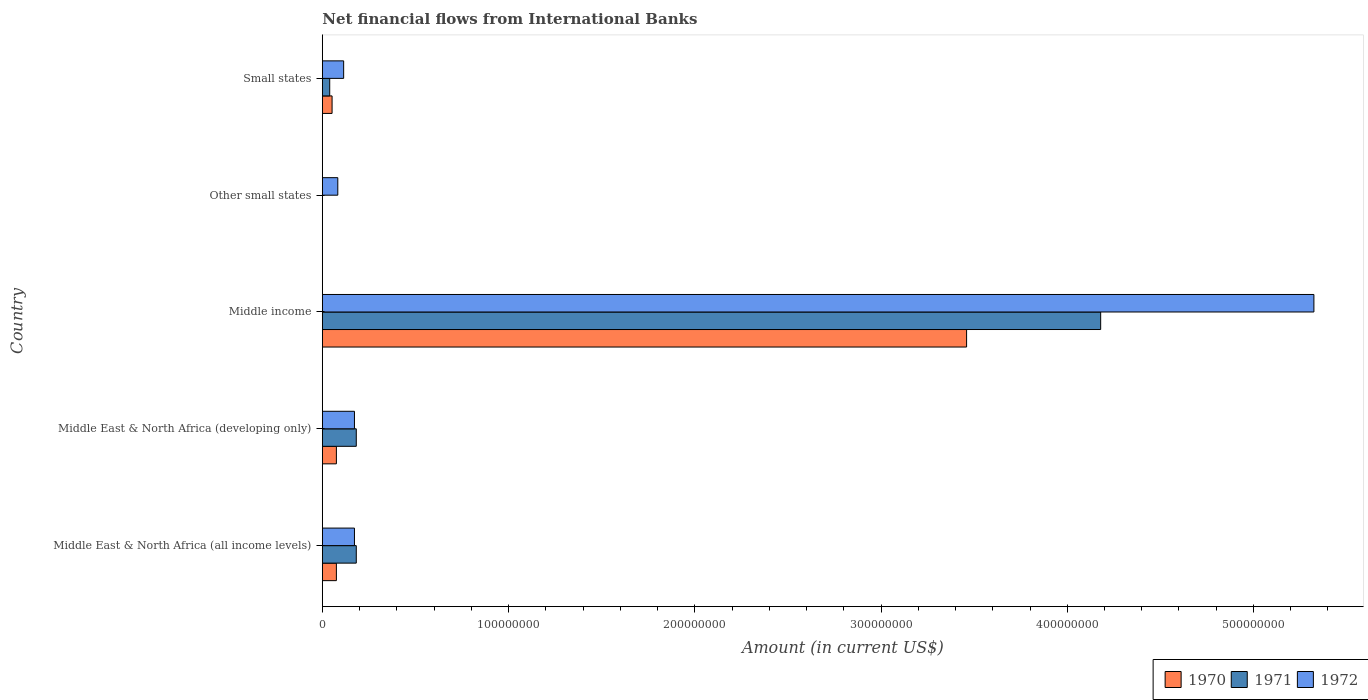How many different coloured bars are there?
Provide a succinct answer. 3. Are the number of bars per tick equal to the number of legend labels?
Make the answer very short. No. How many bars are there on the 1st tick from the bottom?
Offer a terse response. 3. What is the label of the 2nd group of bars from the top?
Your answer should be very brief. Other small states. What is the net financial aid flows in 1972 in Middle East & North Africa (developing only)?
Your response must be concise. 1.73e+07. Across all countries, what is the maximum net financial aid flows in 1972?
Your answer should be compact. 5.32e+08. Across all countries, what is the minimum net financial aid flows in 1970?
Offer a very short reply. 0. In which country was the net financial aid flows in 1972 maximum?
Your answer should be compact. Middle income. What is the total net financial aid flows in 1972 in the graph?
Offer a very short reply. 5.87e+08. What is the difference between the net financial aid flows in 1972 in Middle East & North Africa (developing only) and that in Small states?
Offer a very short reply. 5.80e+06. What is the difference between the net financial aid flows in 1972 in Other small states and the net financial aid flows in 1970 in Small states?
Offer a very short reply. 3.07e+06. What is the average net financial aid flows in 1970 per country?
Your answer should be very brief. 7.33e+07. What is the difference between the net financial aid flows in 1971 and net financial aid flows in 1970 in Middle East & North Africa (developing only)?
Your answer should be compact. 1.07e+07. In how many countries, is the net financial aid flows in 1972 greater than 120000000 US$?
Offer a very short reply. 1. What is the ratio of the net financial aid flows in 1972 in Middle East & North Africa (all income levels) to that in Middle income?
Provide a succinct answer. 0.03. Is the difference between the net financial aid flows in 1971 in Middle East & North Africa (all income levels) and Middle East & North Africa (developing only) greater than the difference between the net financial aid flows in 1970 in Middle East & North Africa (all income levels) and Middle East & North Africa (developing only)?
Give a very brief answer. No. What is the difference between the highest and the second highest net financial aid flows in 1970?
Provide a short and direct response. 3.38e+08. What is the difference between the highest and the lowest net financial aid flows in 1972?
Your response must be concise. 5.24e+08. Is the sum of the net financial aid flows in 1971 in Middle East & North Africa (all income levels) and Middle East & North Africa (developing only) greater than the maximum net financial aid flows in 1972 across all countries?
Offer a terse response. No. What is the difference between two consecutive major ticks on the X-axis?
Your response must be concise. 1.00e+08. Does the graph contain any zero values?
Provide a short and direct response. Yes. How many legend labels are there?
Give a very brief answer. 3. What is the title of the graph?
Your answer should be very brief. Net financial flows from International Banks. Does "1968" appear as one of the legend labels in the graph?
Provide a succinct answer. No. What is the label or title of the X-axis?
Your response must be concise. Amount (in current US$). What is the Amount (in current US$) in 1970 in Middle East & North Africa (all income levels)?
Ensure brevity in your answer.  7.55e+06. What is the Amount (in current US$) of 1971 in Middle East & North Africa (all income levels)?
Your answer should be very brief. 1.82e+07. What is the Amount (in current US$) in 1972 in Middle East & North Africa (all income levels)?
Provide a short and direct response. 1.73e+07. What is the Amount (in current US$) of 1970 in Middle East & North Africa (developing only)?
Offer a terse response. 7.55e+06. What is the Amount (in current US$) in 1971 in Middle East & North Africa (developing only)?
Keep it short and to the point. 1.82e+07. What is the Amount (in current US$) in 1972 in Middle East & North Africa (developing only)?
Provide a succinct answer. 1.73e+07. What is the Amount (in current US$) in 1970 in Middle income?
Keep it short and to the point. 3.46e+08. What is the Amount (in current US$) in 1971 in Middle income?
Give a very brief answer. 4.18e+08. What is the Amount (in current US$) of 1972 in Middle income?
Your response must be concise. 5.32e+08. What is the Amount (in current US$) of 1970 in Other small states?
Your answer should be very brief. 0. What is the Amount (in current US$) of 1971 in Other small states?
Ensure brevity in your answer.  0. What is the Amount (in current US$) of 1972 in Other small states?
Provide a succinct answer. 8.31e+06. What is the Amount (in current US$) of 1970 in Small states?
Your answer should be very brief. 5.24e+06. What is the Amount (in current US$) in 1971 in Small states?
Ensure brevity in your answer.  3.97e+06. What is the Amount (in current US$) of 1972 in Small states?
Your response must be concise. 1.15e+07. Across all countries, what is the maximum Amount (in current US$) in 1970?
Your response must be concise. 3.46e+08. Across all countries, what is the maximum Amount (in current US$) of 1971?
Offer a very short reply. 4.18e+08. Across all countries, what is the maximum Amount (in current US$) in 1972?
Your answer should be compact. 5.32e+08. Across all countries, what is the minimum Amount (in current US$) of 1971?
Your answer should be compact. 0. Across all countries, what is the minimum Amount (in current US$) of 1972?
Your answer should be very brief. 8.31e+06. What is the total Amount (in current US$) of 1970 in the graph?
Your answer should be very brief. 3.66e+08. What is the total Amount (in current US$) of 1971 in the graph?
Make the answer very short. 4.58e+08. What is the total Amount (in current US$) of 1972 in the graph?
Provide a short and direct response. 5.87e+08. What is the difference between the Amount (in current US$) of 1971 in Middle East & North Africa (all income levels) and that in Middle East & North Africa (developing only)?
Make the answer very short. 0. What is the difference between the Amount (in current US$) of 1972 in Middle East & North Africa (all income levels) and that in Middle East & North Africa (developing only)?
Keep it short and to the point. 0. What is the difference between the Amount (in current US$) of 1970 in Middle East & North Africa (all income levels) and that in Middle income?
Provide a short and direct response. -3.38e+08. What is the difference between the Amount (in current US$) in 1971 in Middle East & North Africa (all income levels) and that in Middle income?
Your answer should be very brief. -4.00e+08. What is the difference between the Amount (in current US$) in 1972 in Middle East & North Africa (all income levels) and that in Middle income?
Provide a succinct answer. -5.15e+08. What is the difference between the Amount (in current US$) in 1972 in Middle East & North Africa (all income levels) and that in Other small states?
Your response must be concise. 8.94e+06. What is the difference between the Amount (in current US$) in 1970 in Middle East & North Africa (all income levels) and that in Small states?
Offer a very short reply. 2.31e+06. What is the difference between the Amount (in current US$) of 1971 in Middle East & North Africa (all income levels) and that in Small states?
Offer a terse response. 1.43e+07. What is the difference between the Amount (in current US$) of 1972 in Middle East & North Africa (all income levels) and that in Small states?
Keep it short and to the point. 5.80e+06. What is the difference between the Amount (in current US$) in 1970 in Middle East & North Africa (developing only) and that in Middle income?
Offer a very short reply. -3.38e+08. What is the difference between the Amount (in current US$) of 1971 in Middle East & North Africa (developing only) and that in Middle income?
Your answer should be very brief. -4.00e+08. What is the difference between the Amount (in current US$) in 1972 in Middle East & North Africa (developing only) and that in Middle income?
Offer a very short reply. -5.15e+08. What is the difference between the Amount (in current US$) of 1972 in Middle East & North Africa (developing only) and that in Other small states?
Ensure brevity in your answer.  8.94e+06. What is the difference between the Amount (in current US$) of 1970 in Middle East & North Africa (developing only) and that in Small states?
Keep it short and to the point. 2.31e+06. What is the difference between the Amount (in current US$) in 1971 in Middle East & North Africa (developing only) and that in Small states?
Provide a short and direct response. 1.43e+07. What is the difference between the Amount (in current US$) in 1972 in Middle East & North Africa (developing only) and that in Small states?
Your answer should be very brief. 5.80e+06. What is the difference between the Amount (in current US$) in 1972 in Middle income and that in Other small states?
Offer a terse response. 5.24e+08. What is the difference between the Amount (in current US$) of 1970 in Middle income and that in Small states?
Your answer should be very brief. 3.41e+08. What is the difference between the Amount (in current US$) of 1971 in Middle income and that in Small states?
Provide a short and direct response. 4.14e+08. What is the difference between the Amount (in current US$) of 1972 in Middle income and that in Small states?
Your answer should be compact. 5.21e+08. What is the difference between the Amount (in current US$) of 1972 in Other small states and that in Small states?
Your answer should be compact. -3.15e+06. What is the difference between the Amount (in current US$) of 1970 in Middle East & North Africa (all income levels) and the Amount (in current US$) of 1971 in Middle East & North Africa (developing only)?
Give a very brief answer. -1.07e+07. What is the difference between the Amount (in current US$) of 1970 in Middle East & North Africa (all income levels) and the Amount (in current US$) of 1972 in Middle East & North Africa (developing only)?
Your answer should be very brief. -9.70e+06. What is the difference between the Amount (in current US$) in 1971 in Middle East & North Africa (all income levels) and the Amount (in current US$) in 1972 in Middle East & North Africa (developing only)?
Give a very brief answer. 9.78e+05. What is the difference between the Amount (in current US$) in 1970 in Middle East & North Africa (all income levels) and the Amount (in current US$) in 1971 in Middle income?
Your answer should be very brief. -4.10e+08. What is the difference between the Amount (in current US$) in 1970 in Middle East & North Africa (all income levels) and the Amount (in current US$) in 1972 in Middle income?
Provide a succinct answer. -5.25e+08. What is the difference between the Amount (in current US$) in 1971 in Middle East & North Africa (all income levels) and the Amount (in current US$) in 1972 in Middle income?
Your response must be concise. -5.14e+08. What is the difference between the Amount (in current US$) of 1970 in Middle East & North Africa (all income levels) and the Amount (in current US$) of 1972 in Other small states?
Offer a terse response. -7.62e+05. What is the difference between the Amount (in current US$) in 1971 in Middle East & North Africa (all income levels) and the Amount (in current US$) in 1972 in Other small states?
Your answer should be very brief. 9.92e+06. What is the difference between the Amount (in current US$) in 1970 in Middle East & North Africa (all income levels) and the Amount (in current US$) in 1971 in Small states?
Give a very brief answer. 3.58e+06. What is the difference between the Amount (in current US$) in 1970 in Middle East & North Africa (all income levels) and the Amount (in current US$) in 1972 in Small states?
Provide a short and direct response. -3.91e+06. What is the difference between the Amount (in current US$) in 1971 in Middle East & North Africa (all income levels) and the Amount (in current US$) in 1972 in Small states?
Make the answer very short. 6.77e+06. What is the difference between the Amount (in current US$) in 1970 in Middle East & North Africa (developing only) and the Amount (in current US$) in 1971 in Middle income?
Provide a succinct answer. -4.10e+08. What is the difference between the Amount (in current US$) in 1970 in Middle East & North Africa (developing only) and the Amount (in current US$) in 1972 in Middle income?
Your answer should be compact. -5.25e+08. What is the difference between the Amount (in current US$) in 1971 in Middle East & North Africa (developing only) and the Amount (in current US$) in 1972 in Middle income?
Offer a terse response. -5.14e+08. What is the difference between the Amount (in current US$) of 1970 in Middle East & North Africa (developing only) and the Amount (in current US$) of 1972 in Other small states?
Ensure brevity in your answer.  -7.62e+05. What is the difference between the Amount (in current US$) in 1971 in Middle East & North Africa (developing only) and the Amount (in current US$) in 1972 in Other small states?
Offer a terse response. 9.92e+06. What is the difference between the Amount (in current US$) in 1970 in Middle East & North Africa (developing only) and the Amount (in current US$) in 1971 in Small states?
Your answer should be compact. 3.58e+06. What is the difference between the Amount (in current US$) in 1970 in Middle East & North Africa (developing only) and the Amount (in current US$) in 1972 in Small states?
Offer a very short reply. -3.91e+06. What is the difference between the Amount (in current US$) of 1971 in Middle East & North Africa (developing only) and the Amount (in current US$) of 1972 in Small states?
Keep it short and to the point. 6.77e+06. What is the difference between the Amount (in current US$) of 1970 in Middle income and the Amount (in current US$) of 1972 in Other small states?
Your response must be concise. 3.38e+08. What is the difference between the Amount (in current US$) in 1971 in Middle income and the Amount (in current US$) in 1972 in Other small states?
Offer a terse response. 4.10e+08. What is the difference between the Amount (in current US$) of 1970 in Middle income and the Amount (in current US$) of 1971 in Small states?
Provide a succinct answer. 3.42e+08. What is the difference between the Amount (in current US$) in 1970 in Middle income and the Amount (in current US$) in 1972 in Small states?
Your answer should be very brief. 3.34e+08. What is the difference between the Amount (in current US$) in 1971 in Middle income and the Amount (in current US$) in 1972 in Small states?
Your answer should be compact. 4.06e+08. What is the average Amount (in current US$) of 1970 per country?
Your response must be concise. 7.33e+07. What is the average Amount (in current US$) of 1971 per country?
Offer a terse response. 9.17e+07. What is the average Amount (in current US$) in 1972 per country?
Provide a short and direct response. 1.17e+08. What is the difference between the Amount (in current US$) of 1970 and Amount (in current US$) of 1971 in Middle East & North Africa (all income levels)?
Offer a terse response. -1.07e+07. What is the difference between the Amount (in current US$) of 1970 and Amount (in current US$) of 1972 in Middle East & North Africa (all income levels)?
Provide a short and direct response. -9.70e+06. What is the difference between the Amount (in current US$) of 1971 and Amount (in current US$) of 1972 in Middle East & North Africa (all income levels)?
Offer a terse response. 9.78e+05. What is the difference between the Amount (in current US$) of 1970 and Amount (in current US$) of 1971 in Middle East & North Africa (developing only)?
Keep it short and to the point. -1.07e+07. What is the difference between the Amount (in current US$) in 1970 and Amount (in current US$) in 1972 in Middle East & North Africa (developing only)?
Offer a terse response. -9.70e+06. What is the difference between the Amount (in current US$) of 1971 and Amount (in current US$) of 1972 in Middle East & North Africa (developing only)?
Ensure brevity in your answer.  9.78e+05. What is the difference between the Amount (in current US$) in 1970 and Amount (in current US$) in 1971 in Middle income?
Give a very brief answer. -7.20e+07. What is the difference between the Amount (in current US$) in 1970 and Amount (in current US$) in 1972 in Middle income?
Your answer should be compact. -1.87e+08. What is the difference between the Amount (in current US$) of 1971 and Amount (in current US$) of 1972 in Middle income?
Offer a terse response. -1.15e+08. What is the difference between the Amount (in current US$) of 1970 and Amount (in current US$) of 1971 in Small states?
Your response must be concise. 1.27e+06. What is the difference between the Amount (in current US$) in 1970 and Amount (in current US$) in 1972 in Small states?
Ensure brevity in your answer.  -6.22e+06. What is the difference between the Amount (in current US$) of 1971 and Amount (in current US$) of 1972 in Small states?
Ensure brevity in your answer.  -7.49e+06. What is the ratio of the Amount (in current US$) in 1970 in Middle East & North Africa (all income levels) to that in Middle East & North Africa (developing only)?
Your answer should be very brief. 1. What is the ratio of the Amount (in current US$) in 1972 in Middle East & North Africa (all income levels) to that in Middle East & North Africa (developing only)?
Ensure brevity in your answer.  1. What is the ratio of the Amount (in current US$) in 1970 in Middle East & North Africa (all income levels) to that in Middle income?
Provide a succinct answer. 0.02. What is the ratio of the Amount (in current US$) in 1971 in Middle East & North Africa (all income levels) to that in Middle income?
Give a very brief answer. 0.04. What is the ratio of the Amount (in current US$) of 1972 in Middle East & North Africa (all income levels) to that in Middle income?
Your answer should be very brief. 0.03. What is the ratio of the Amount (in current US$) in 1972 in Middle East & North Africa (all income levels) to that in Other small states?
Provide a succinct answer. 2.08. What is the ratio of the Amount (in current US$) of 1970 in Middle East & North Africa (all income levels) to that in Small states?
Offer a terse response. 1.44. What is the ratio of the Amount (in current US$) of 1971 in Middle East & North Africa (all income levels) to that in Small states?
Give a very brief answer. 4.59. What is the ratio of the Amount (in current US$) in 1972 in Middle East & North Africa (all income levels) to that in Small states?
Offer a very short reply. 1.51. What is the ratio of the Amount (in current US$) of 1970 in Middle East & North Africa (developing only) to that in Middle income?
Offer a very short reply. 0.02. What is the ratio of the Amount (in current US$) in 1971 in Middle East & North Africa (developing only) to that in Middle income?
Your answer should be very brief. 0.04. What is the ratio of the Amount (in current US$) in 1972 in Middle East & North Africa (developing only) to that in Middle income?
Keep it short and to the point. 0.03. What is the ratio of the Amount (in current US$) of 1972 in Middle East & North Africa (developing only) to that in Other small states?
Offer a very short reply. 2.08. What is the ratio of the Amount (in current US$) of 1970 in Middle East & North Africa (developing only) to that in Small states?
Give a very brief answer. 1.44. What is the ratio of the Amount (in current US$) of 1971 in Middle East & North Africa (developing only) to that in Small states?
Your answer should be compact. 4.59. What is the ratio of the Amount (in current US$) of 1972 in Middle East & North Africa (developing only) to that in Small states?
Provide a short and direct response. 1.51. What is the ratio of the Amount (in current US$) of 1972 in Middle income to that in Other small states?
Ensure brevity in your answer.  64.08. What is the ratio of the Amount (in current US$) in 1970 in Middle income to that in Small states?
Give a very brief answer. 66.08. What is the ratio of the Amount (in current US$) in 1971 in Middle income to that in Small states?
Your answer should be very brief. 105.33. What is the ratio of the Amount (in current US$) in 1972 in Middle income to that in Small states?
Ensure brevity in your answer.  46.48. What is the ratio of the Amount (in current US$) in 1972 in Other small states to that in Small states?
Your answer should be very brief. 0.73. What is the difference between the highest and the second highest Amount (in current US$) of 1970?
Keep it short and to the point. 3.38e+08. What is the difference between the highest and the second highest Amount (in current US$) of 1971?
Keep it short and to the point. 4.00e+08. What is the difference between the highest and the second highest Amount (in current US$) of 1972?
Your answer should be very brief. 5.15e+08. What is the difference between the highest and the lowest Amount (in current US$) of 1970?
Your answer should be compact. 3.46e+08. What is the difference between the highest and the lowest Amount (in current US$) in 1971?
Provide a succinct answer. 4.18e+08. What is the difference between the highest and the lowest Amount (in current US$) in 1972?
Your response must be concise. 5.24e+08. 